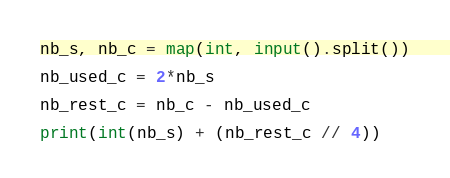Convert code to text. <code><loc_0><loc_0><loc_500><loc_500><_Python_>nb_s, nb_c = map(int, input().split())

nb_used_c = 2*nb_s

nb_rest_c = nb_c - nb_used_c

print(int(nb_s) + (nb_rest_c // 4))</code> 